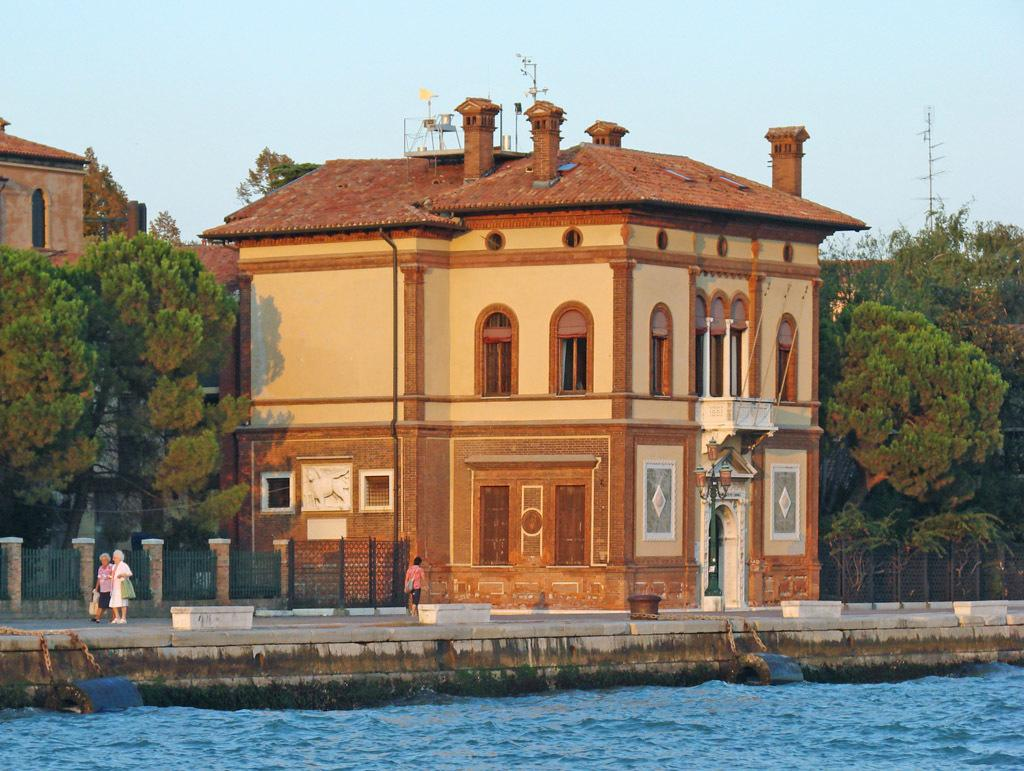What is located in the center of the image? There are buildings in the center of the image. What are the people at the bottom of the image doing? People are walking at the bottom of the image. What natural element can be seen in the image? There is water visible in the image. What type of vegetation is in the background of the image? There are trees in the background of the image. What is present in the background of the image besides trees? There is a pole and the sky visible in the background of the image. What type of barrier is in the image? There is a fence in the image. What type of winter sport is being played in the image? There is no winter sport or any indication of winter in the image. Who is the expert in the image? There is no expert or any indication of expertise in the image. 